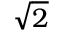Convert formula to latex. <formula><loc_0><loc_0><loc_500><loc_500>\sqrt { 2 }</formula> 